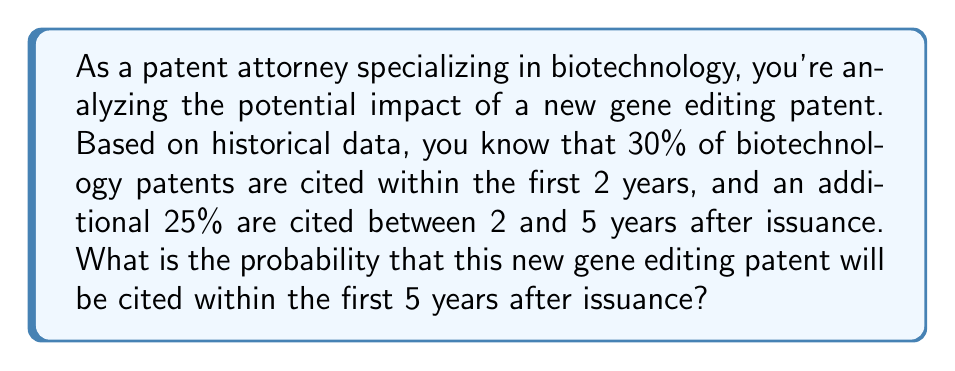Provide a solution to this math problem. To solve this problem, we need to consider the probabilities of the patent being cited in two distinct time periods and combine them. Let's break it down step-by-step:

1) Let's define our events:
   A: The patent is cited within the first 2 years
   B: The patent is cited between 2 and 5 years

2) Given probabilities:
   P(A) = 30% = 0.30
   P(B) = 25% = 0.25

3) We want to find the probability of the patent being cited within 5 years, which is equivalent to the probability of it being cited either within the first 2 years OR between 2 and 5 years.

4) This is a union of two events: P(A ∪ B)

5) The formula for the union of two events is:
   P(A ∪ B) = P(A) + P(B) - P(A ∩ B)

6) However, in this case, A and B are mutually exclusive events (a patent can't be cited for the first time in both periods), so P(A ∩ B) = 0

7) Therefore, our calculation simplifies to:
   P(A ∪ B) = P(A) + P(B)

8) Substituting the values:
   P(A ∪ B) = 0.30 + 0.25 = 0.55

9) Converting to a percentage:
   0.55 * 100 = 55%

Therefore, the probability that the new gene editing patent will be cited within the first 5 years after issuance is 55%.
Answer: 55% 